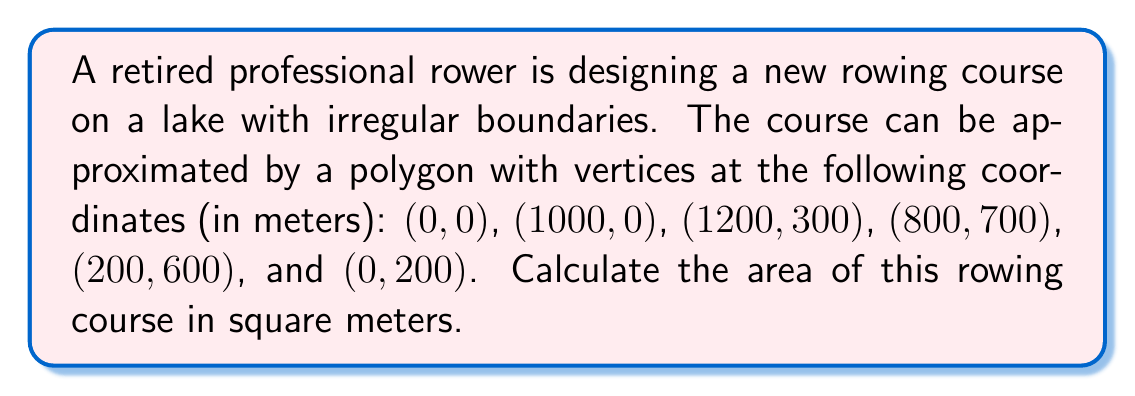Give your solution to this math problem. To calculate the area of this irregular polygon, we can use the Shoelace formula (also known as the surveyor's formula). This formula is particularly useful for calculating the area of a polygon given its vertices.

The Shoelace formula is:

$$ A = \frac{1}{2}\left|\sum_{i=1}^{n-1} (x_iy_{i+1} + x_ny_1) - \sum_{i=1}^{n-1} (y_ix_{i+1} + y_nx_1)\right| $$

Where $(x_i, y_i)$ are the coordinates of the $i$-th vertex, and $n$ is the number of vertices.

Let's apply this formula to our polygon:

1) First, let's list our vertices in order:
   $(x_1, y_1) = (0, 0)$
   $(x_2, y_2) = (1000, 0)$
   $(x_3, y_3) = (1200, 300)$
   $(x_4, y_4) = (800, 700)$
   $(x_5, y_5) = (200, 600)$
   $(x_6, y_6) = (0, 200)$

2) Now, let's calculate the first sum:
   $S_1 = (0 \cdot 0) + (1000 \cdot 300) + (1200 \cdot 700) + (800 \cdot 600) + (200 \cdot 200) + (0 \cdot 0)$
   $S_1 = 0 + 300000 + 840000 + 480000 + 40000 + 0 = 1660000$

3) Calculate the second sum:
   $S_2 = (0 \cdot 1000) + (0 \cdot 1200) + (300 \cdot 800) + (700 \cdot 200) + (600 \cdot 0) + (200 \cdot 0)$
   $S_2 = 0 + 0 + 240000 + 140000 + 0 + 0 = 380000$

4) Subtract $S_2$ from $S_1$:
   $S_1 - S_2 = 1660000 - 380000 = 1280000$

5) Multiply by $\frac{1}{2}$:
   $A = \frac{1}{2} \cdot 1280000 = 640000$

Therefore, the area of the rowing course is 640,000 square meters.

[asy]
unitsize(0.1mm);
draw((0,0)--(1000,0)--(1200,300)--(800,700)--(200,600)--(0,200)--cycle);
label("(0,0)", (0,0), SW);
label("(1000,0)", (1000,0), SE);
label("(1200,300)", (1200,300), E);
label("(800,700)", (800,700), NE);
label("(200,600)", (200,600), NW);
label("(0,200)", (0,200), W);
[/asy]
Answer: 640,000 square meters 